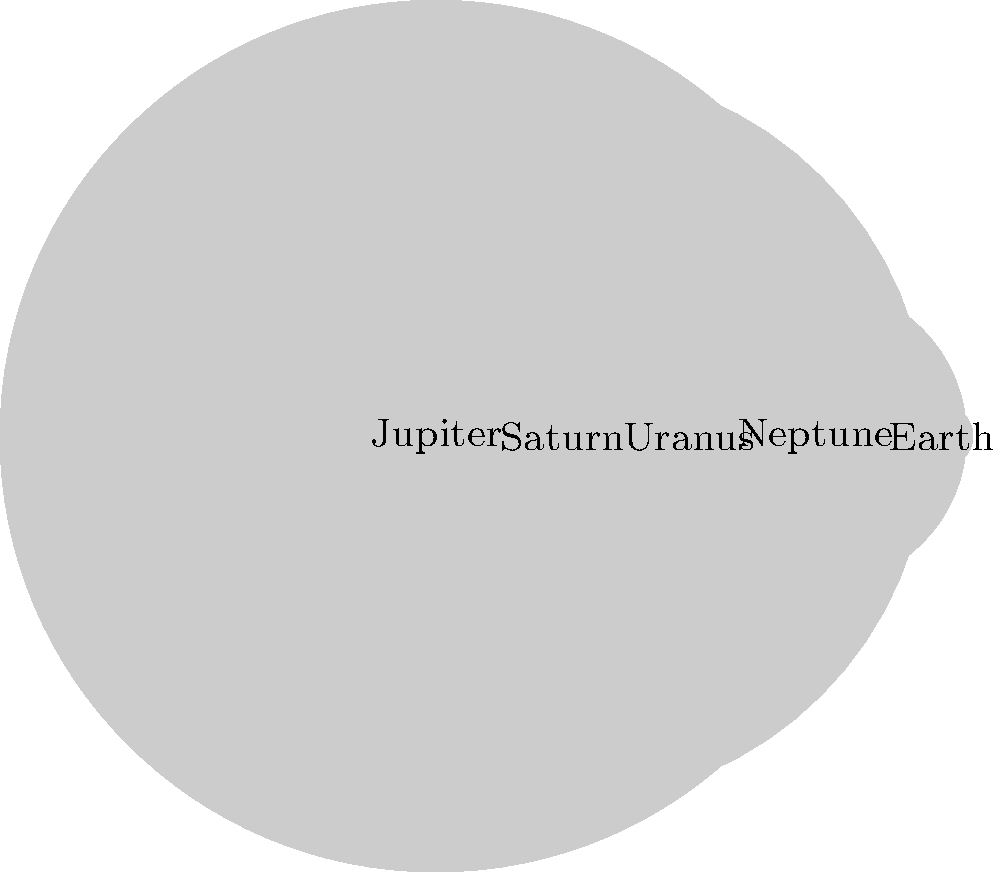During a challenging day at work, you find solace in contemplating the vastness of space. Looking at this diagram of scaled planet sizes, how many times larger is Jupiter's diameter compared to Earth's? Let's approach this step-by-step:

1. In the diagram, we can see that the planets are represented by circles of different sizes.

2. The sizes of the circles are proportional to the actual diameters of the planets.

3. We need to compare the diameters of Jupiter and Earth.

4. In the diagram:
   - Jupiter's circle has a radius of 6.9 units
   - Earth's circle has a radius of 0.5 units

5. To find the diameter, we need to double the radius:
   - Jupiter's diameter = 2 * 6.9 = 13.8 units
   - Earth's diameter = 2 * 0.5 = 1 unit

6. To find how many times larger Jupiter is, we divide Jupiter's diameter by Earth's diameter:
   $$ \frac{\text{Jupiter's diameter}}{\text{Earth's diameter}} = \frac{13.8}{1} = 13.8 $$

7. Therefore, Jupiter's diameter is 13.8 times larger than Earth's diameter.

This cosmic perspective can provide a moment of peace and help put daily struggles into a broader context.
Answer: 13.8 times 